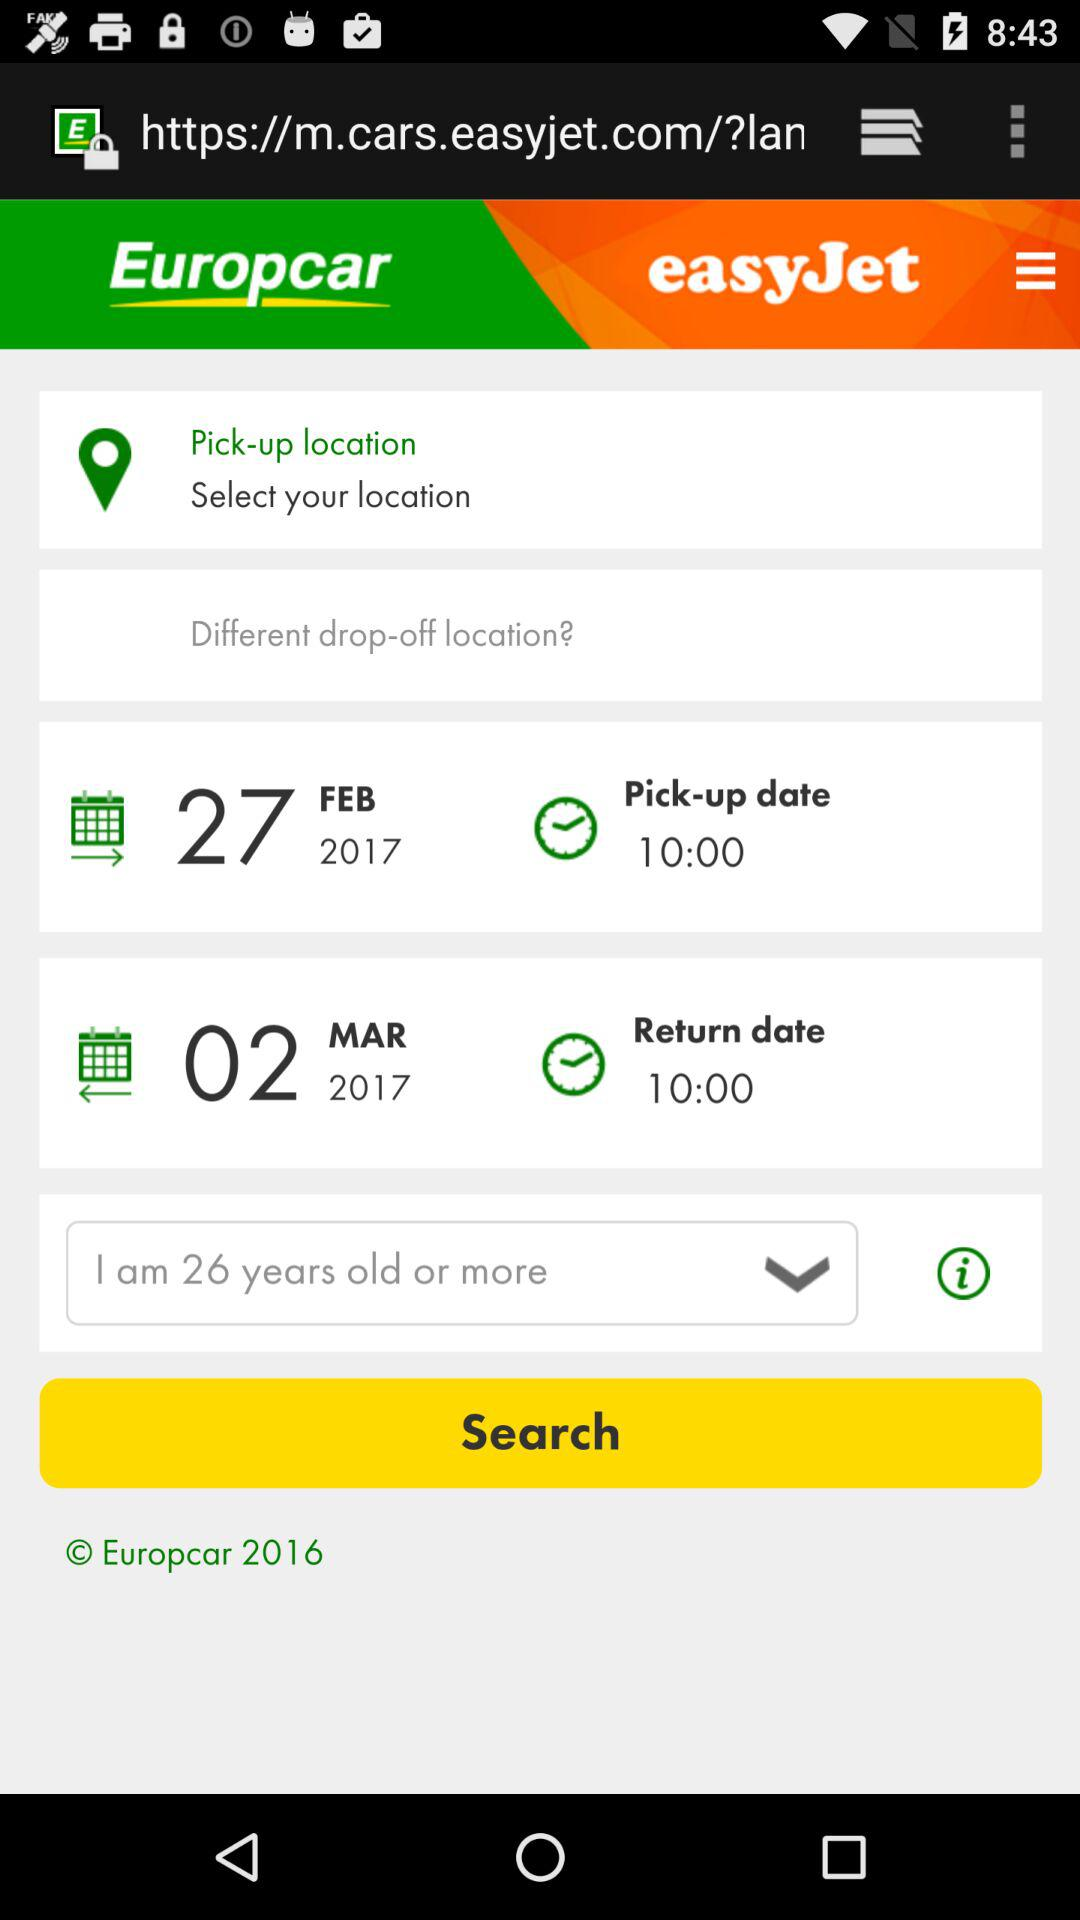What is the name of the application? The names of the applications are "Europcar" and "easyJet". 